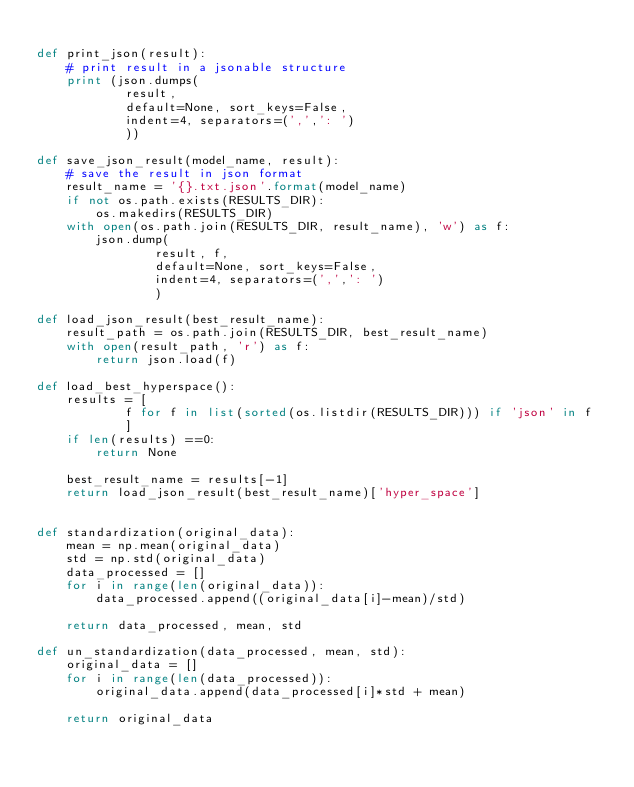Convert code to text. <code><loc_0><loc_0><loc_500><loc_500><_Python_>
def print_json(result):
    # print result in a jsonable structure
    print (json.dumps(
            result,
            default=None, sort_keys=False, 
            indent=4, separators=(',',': ')
            ))

def save_json_result(model_name, result):
    # save the result in json format
    result_name = '{}.txt.json'.format(model_name)
    if not os.path.exists(RESULTS_DIR):
        os.makedirs(RESULTS_DIR)
    with open(os.path.join(RESULTS_DIR, result_name), 'w') as f:
        json.dump(
                result, f,
                default=None, sort_keys=False, 
                indent=4, separators=(',',': ')
                )
        
def load_json_result(best_result_name):
    result_path = os.path.join(RESULTS_DIR, best_result_name)
    with open(result_path, 'r') as f:
        return json.load(f)
        
def load_best_hyperspace():
    results = [
            f for f in list(sorted(os.listdir(RESULTS_DIR))) if 'json' in f
            ]
    if len(results) ==0:
        return None
    
    best_result_name = results[-1]
    return load_json_result(best_result_name)['hyper_space']
    
   
def standardization(original_data):
    mean = np.mean(original_data)
    std = np.std(original_data)
    data_processed = []
    for i in range(len(original_data)):
        data_processed.append((original_data[i]-mean)/std)
        
    return data_processed, mean, std

def un_standardization(data_processed, mean, std):
    original_data = []
    for i in range(len(data_processed)):
        original_data.append(data_processed[i]*std + mean)
    
    return original_data
</code> 